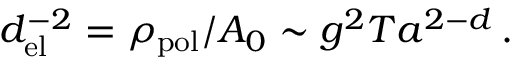<formula> <loc_0><loc_0><loc_500><loc_500>d _ { e l } ^ { - 2 } = \rho _ { p o l } / A _ { 0 } \sim g ^ { 2 } T a ^ { 2 - d } \, .</formula> 